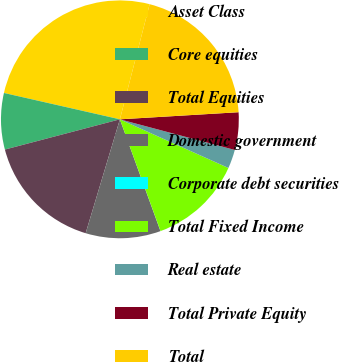Convert chart. <chart><loc_0><loc_0><loc_500><loc_500><pie_chart><fcel>Asset Class<fcel>Core equities<fcel>Total Equities<fcel>Domestic government<fcel>Corporate debt securities<fcel>Total Fixed Income<fcel>Real estate<fcel>Total Private Equity<fcel>Total<nl><fcel>25.47%<fcel>7.65%<fcel>16.26%<fcel>10.19%<fcel>0.01%<fcel>12.74%<fcel>2.56%<fcel>5.1%<fcel>20.02%<nl></chart> 